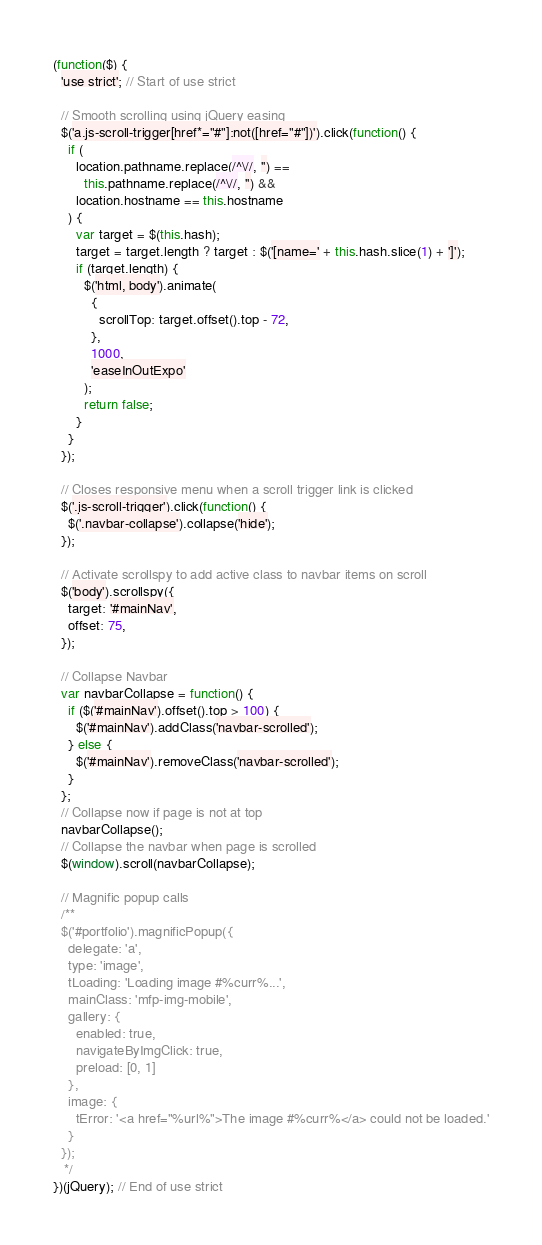<code> <loc_0><loc_0><loc_500><loc_500><_JavaScript_>(function($) {
  'use strict'; // Start of use strict

  // Smooth scrolling using jQuery easing
  $('a.js-scroll-trigger[href*="#"]:not([href="#"])').click(function() {
    if (
      location.pathname.replace(/^\//, '') ==
        this.pathname.replace(/^\//, '') &&
      location.hostname == this.hostname
    ) {
      var target = $(this.hash);
      target = target.length ? target : $('[name=' + this.hash.slice(1) + ']');
      if (target.length) {
        $('html, body').animate(
          {
            scrollTop: target.offset().top - 72,
          },
          1000,
          'easeInOutExpo'
        );
        return false;
      }
    }
  });

  // Closes responsive menu when a scroll trigger link is clicked
  $('.js-scroll-trigger').click(function() {
    $('.navbar-collapse').collapse('hide');
  });

  // Activate scrollspy to add active class to navbar items on scroll
  $('body').scrollspy({
    target: '#mainNav',
    offset: 75,
  });

  // Collapse Navbar
  var navbarCollapse = function() {
    if ($('#mainNav').offset().top > 100) {
      $('#mainNav').addClass('navbar-scrolled');
    } else {
      $('#mainNav').removeClass('navbar-scrolled');
    }
  };
  // Collapse now if page is not at top
  navbarCollapse();
  // Collapse the navbar when page is scrolled
  $(window).scroll(navbarCollapse);

  // Magnific popup calls
  /**
  $('#portfolio').magnificPopup({
    delegate: 'a',
    type: 'image',
    tLoading: 'Loading image #%curr%...',
    mainClass: 'mfp-img-mobile',
    gallery: {
      enabled: true,
      navigateByImgClick: true,
      preload: [0, 1]
    },
    image: {
      tError: '<a href="%url%">The image #%curr%</a> could not be loaded.'
    }
  });
   */
})(jQuery); // End of use strict
</code> 